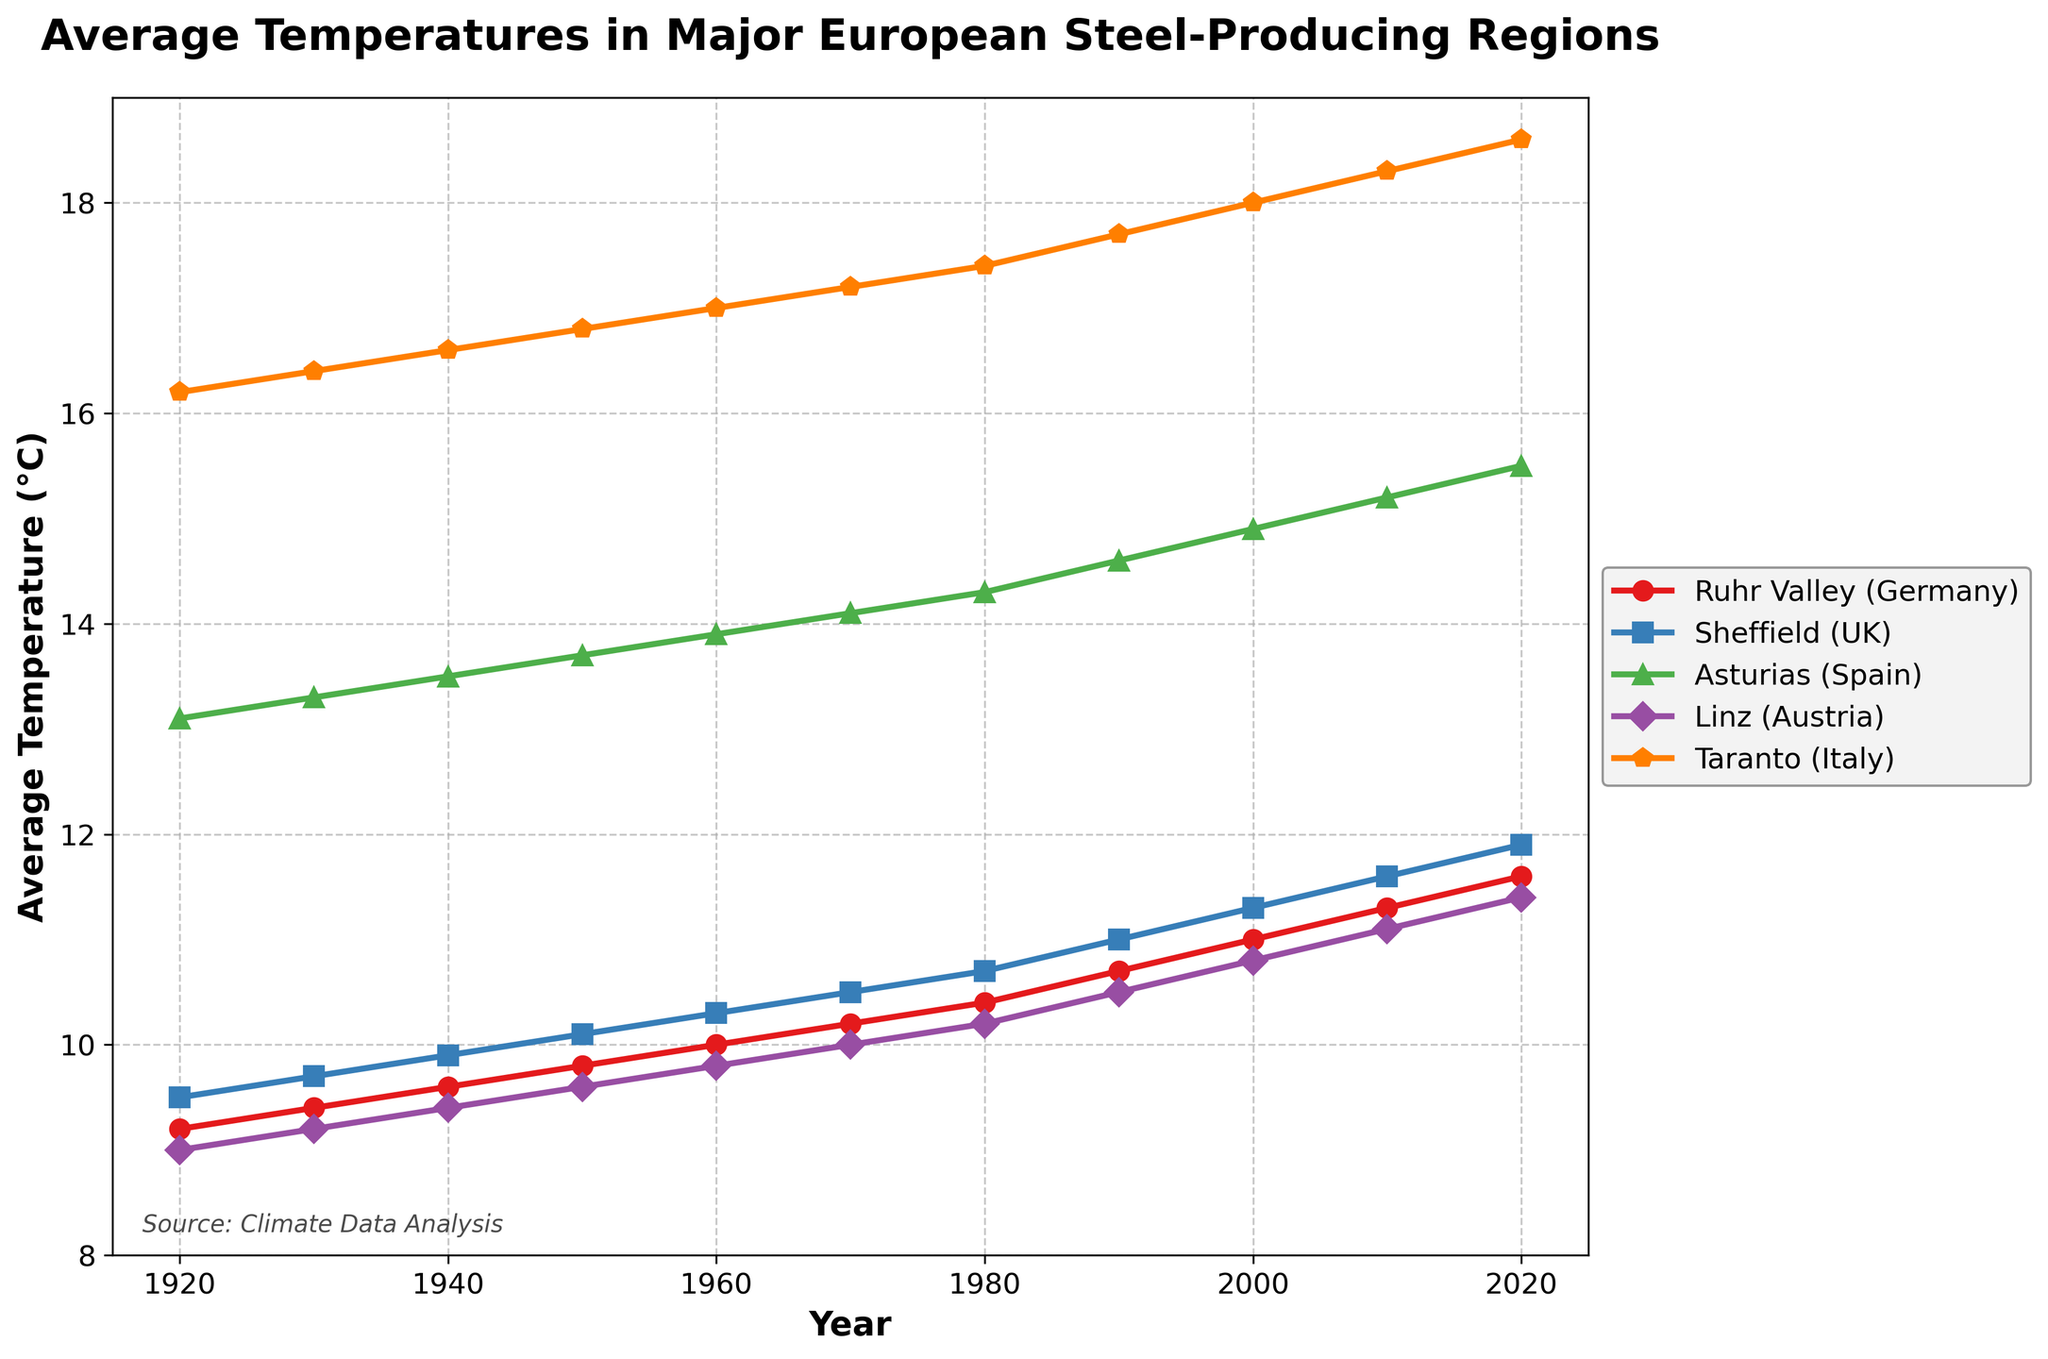Which region experienced the highest increase in average temperature from 1920 to 2020? To determine the highest increase, subtract the 1920 temperature from the 2020 temperature for each region. Ruhr Valley: 11.6 - 9.2 = 2.4, Sheffield: 11.9 - 9.5 = 2.4, Asturias: 15.5 - 13.1 = 2.4, Linz: 11.4 - 9.0 = 2.4, Taranto: 18.6 - 16.2 = 2.4. Therefore, all regions experienced the same increase of 2.4°C.
Answer: 2.4°C Which two regions had the same temperature in 1930? Observe the temperatures in 1930. Ruhr Valley: 9.4, Sheffield: 9.7, Asturias: 13.3, Linz: 9.2, Taranto: 16.4. None of the regions had the same temperature in 1930.
Answer: None What is the difference in average temperatures between the hottest and coldest regions in 2020? Identify the highest and lowest temperatures in 2020: Taranto (18.6°C) and Ruhr Valley (11.6°C). Compute the difference: 18.6 - 11.6 = 7.0.
Answer: 7.0°C In which year did Sheffield’s average temperature first exceed 10°C? Look at Sheffield's temperatures over the years: 1920 (9.5), 1930 (9.7), 1940 (9.9), 1950 (10.1). The first instance where the temperature exceeds 10°C is 1950.
Answer: 1950 During which decade did Linz see the largest average temperature increase? Calculate the temperature changes per decade for Linz: 1920-30 (0.2), 1930-40 (0.2), 1940-50 (0.2), 1950-60 (0.2), 1960-70 (0.2), 1970-80 (0.2), 1980-90 (0.3), 1990-2000 (0.3), 2000-10 (0.3), 2010-20 (0.3). The largest increase is 0.3°C, happening during 1980-90 onwards.
Answer: 1980-90 onwards How does the temperature trend of Taranto compare to that of Ruhr Valley over the century? Observe the temperature trends across the years. Both regions show a steady increase. Specifically, Ruhr Valley started at 9.2°C and reached 11.6°C, Taranto started at 16.2°C and reached 18.6°C. Both exhibit increasing trends, but Taranto remains substantially hotter throughout the century.
Answer: Similar trend, but Taranto consistently hotter By how much did average temperatures in Asturias change between 1960 and 2000? Look at the temperatures for Asturias in 1960 (13.9°C) and 2000 (14.9°C). Compute the difference: 14.9 - 13.9 = 1.0.
Answer: 1.0°C If you average the temperatures of Sheffield and Linz in 1980, what do you get? The temperatures in 1980 are: Sheffield (10.7°C) and Linz (10.2°C). Compute the average: (10.7 + 10.2) / 2 = 10.45.
Answer: 10.45°C Which region had the steepest temperature rise between 2010 and 2020? Calculate the temperature increase for each region between 2010 and 2020: Ruhr Valley (11.6 - 11.3 = 0.3), Sheffield (11.9 - 11.6 = 0.3), Asturias (15.5 - 15.2 = 0.3), Linz (11.4 - 11.1 = 0.3), Taranto (18.6 - 18.3 = 0.3). All regions experienced an increase of 0.3°C.
Answer: All regions the same, 0.3°C 